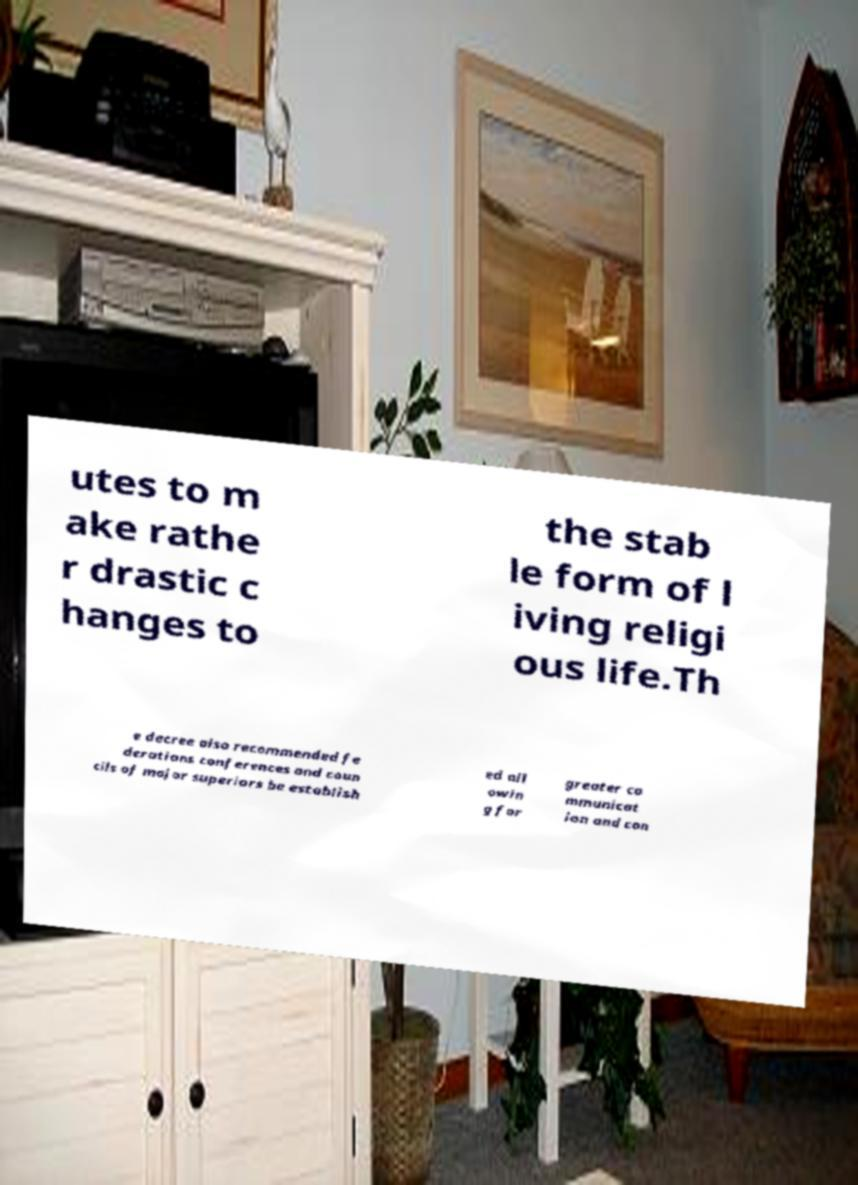For documentation purposes, I need the text within this image transcribed. Could you provide that? utes to m ake rathe r drastic c hanges to the stab le form of l iving religi ous life.Th e decree also recommended fe derations conferences and coun cils of major superiors be establish ed all owin g for greater co mmunicat ion and con 